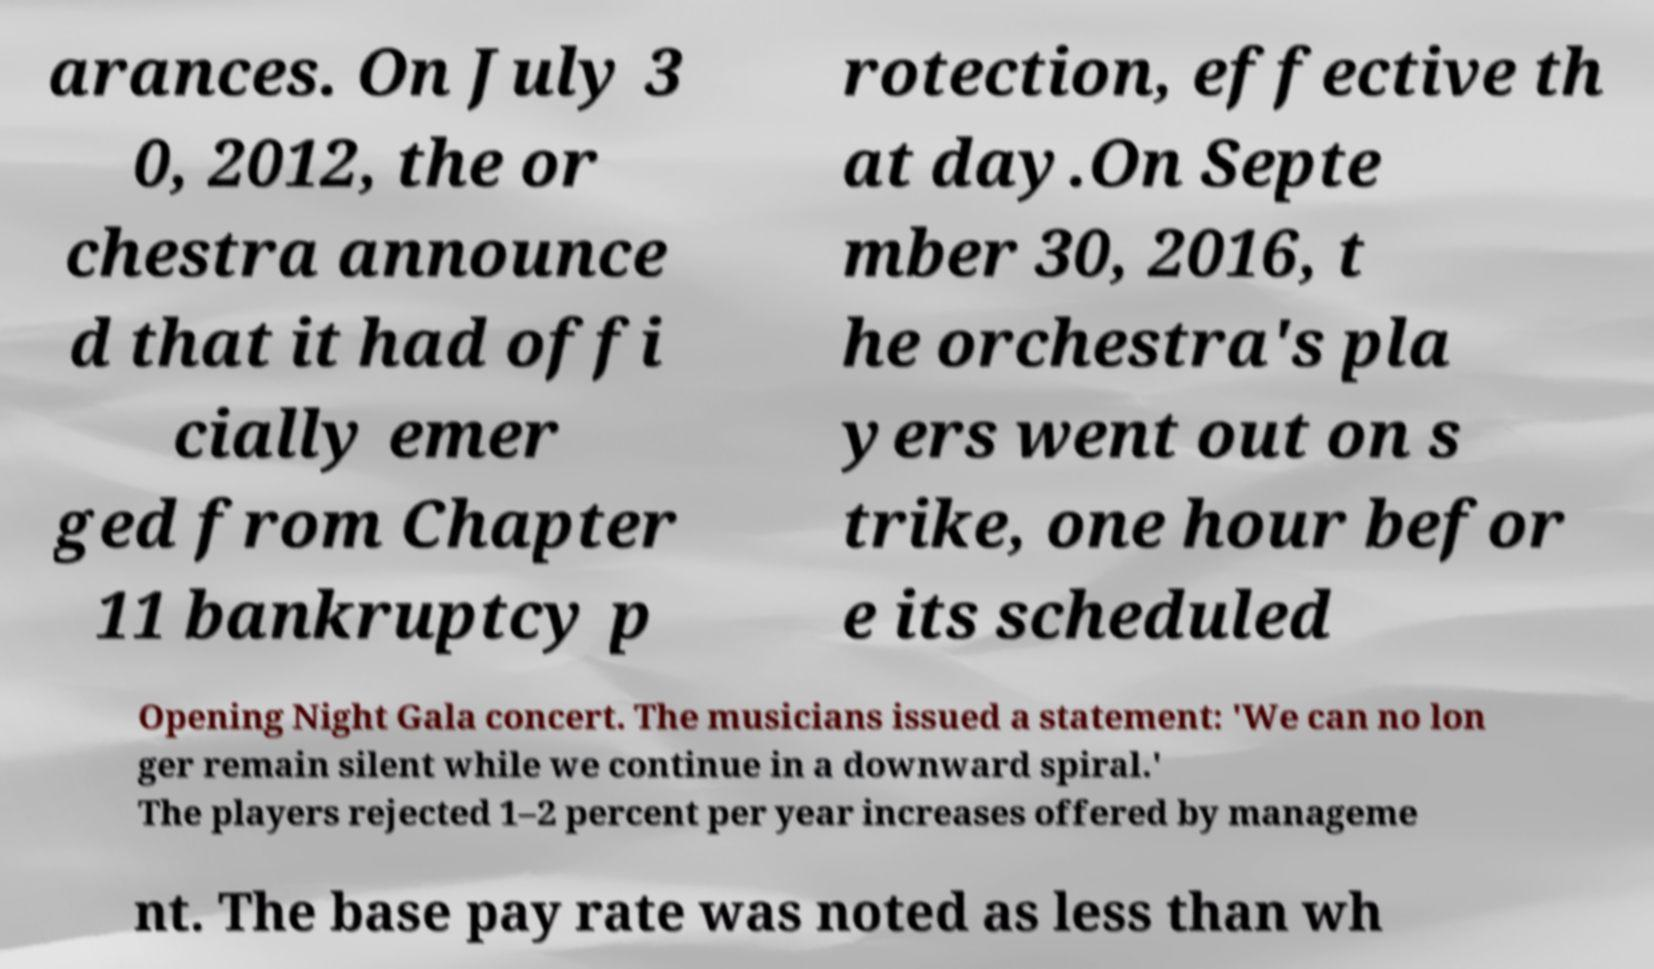I need the written content from this picture converted into text. Can you do that? arances. On July 3 0, 2012, the or chestra announce d that it had offi cially emer ged from Chapter 11 bankruptcy p rotection, effective th at day.On Septe mber 30, 2016, t he orchestra's pla yers went out on s trike, one hour befor e its scheduled Opening Night Gala concert. The musicians issued a statement: 'We can no lon ger remain silent while we continue in a downward spiral.' The players rejected 1–2 percent per year increases offered by manageme nt. The base pay rate was noted as less than wh 